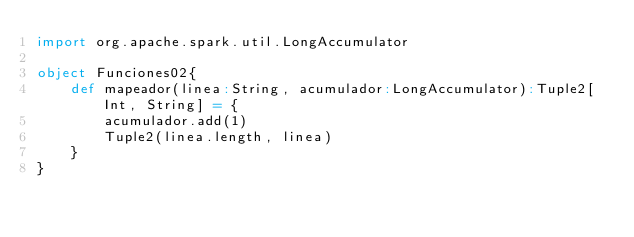<code> <loc_0><loc_0><loc_500><loc_500><_Scala_>import org.apache.spark.util.LongAccumulator

object Funciones02{
	def mapeador(linea:String, acumulador:LongAccumulator):Tuple2[Int, String] = {
		acumulador.add(1)
		Tuple2(linea.length, linea)
	}
}</code> 